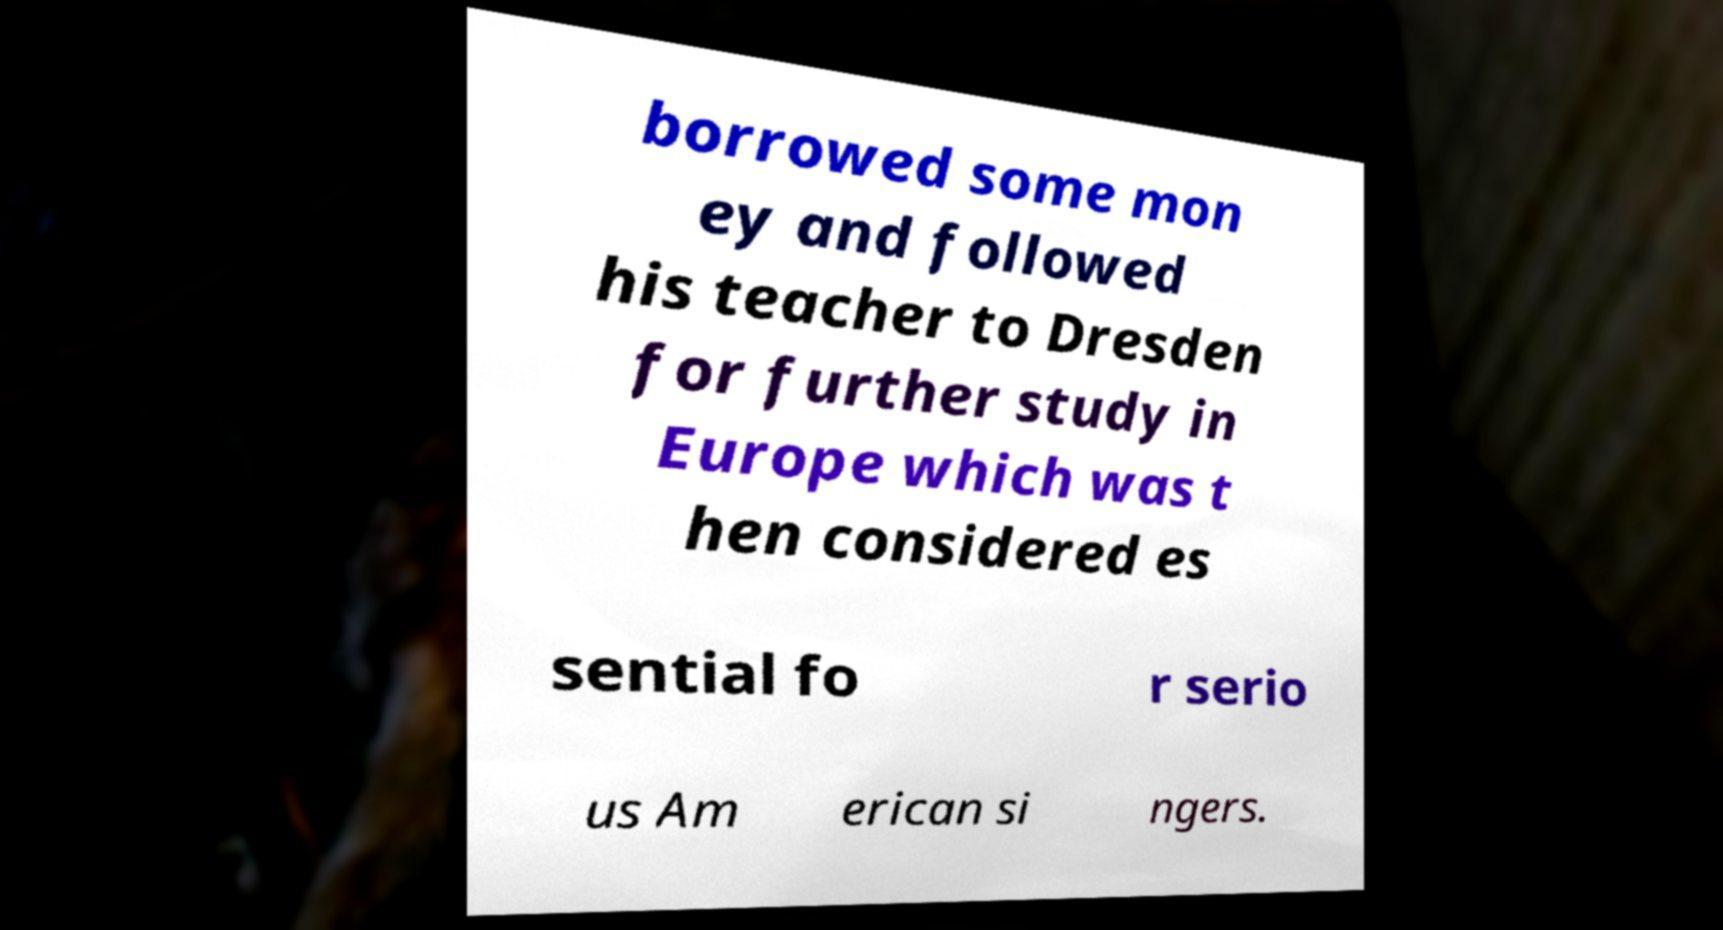Could you extract and type out the text from this image? borrowed some mon ey and followed his teacher to Dresden for further study in Europe which was t hen considered es sential fo r serio us Am erican si ngers. 